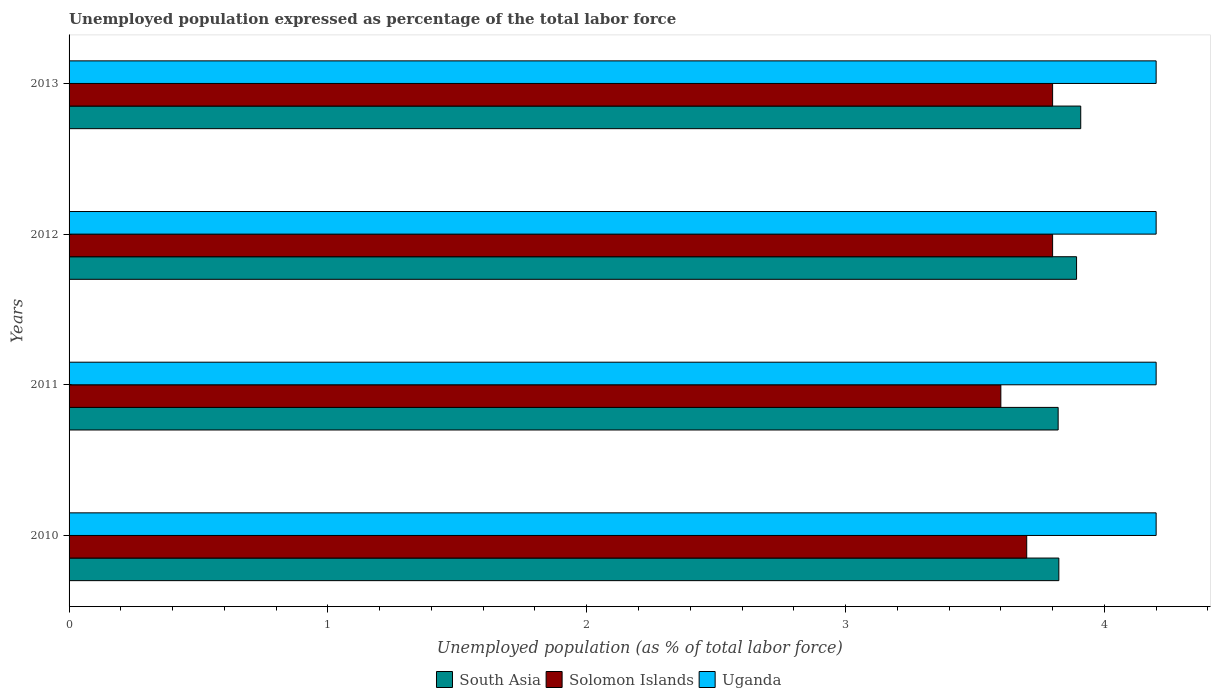How many different coloured bars are there?
Provide a short and direct response. 3. Are the number of bars per tick equal to the number of legend labels?
Make the answer very short. Yes. How many bars are there on the 4th tick from the top?
Your answer should be very brief. 3. What is the unemployment in in Solomon Islands in 2013?
Offer a very short reply. 3.8. Across all years, what is the maximum unemployment in in South Asia?
Provide a short and direct response. 3.91. Across all years, what is the minimum unemployment in in Solomon Islands?
Provide a short and direct response. 3.6. In which year was the unemployment in in Uganda maximum?
Give a very brief answer. 2010. In which year was the unemployment in in South Asia minimum?
Your response must be concise. 2011. What is the total unemployment in in South Asia in the graph?
Your response must be concise. 15.45. What is the difference between the unemployment in in Uganda in 2010 and that in 2011?
Provide a succinct answer. 0. What is the difference between the unemployment in in South Asia in 2011 and the unemployment in in Uganda in 2012?
Ensure brevity in your answer.  -0.38. What is the average unemployment in in Uganda per year?
Your answer should be compact. 4.2. In the year 2012, what is the difference between the unemployment in in Uganda and unemployment in in Solomon Islands?
Provide a succinct answer. 0.4. What is the ratio of the unemployment in in Solomon Islands in 2010 to that in 2012?
Your response must be concise. 0.97. Is the unemployment in in South Asia in 2010 less than that in 2012?
Provide a short and direct response. Yes. What is the difference between the highest and the lowest unemployment in in South Asia?
Keep it short and to the point. 0.09. Is the sum of the unemployment in in Uganda in 2011 and 2013 greater than the maximum unemployment in in South Asia across all years?
Your response must be concise. Yes. What does the 3rd bar from the top in 2013 represents?
Offer a very short reply. South Asia. What does the 2nd bar from the bottom in 2013 represents?
Provide a succinct answer. Solomon Islands. How many bars are there?
Offer a terse response. 12. Are all the bars in the graph horizontal?
Keep it short and to the point. Yes. How many years are there in the graph?
Give a very brief answer. 4. Are the values on the major ticks of X-axis written in scientific E-notation?
Provide a succinct answer. No. Where does the legend appear in the graph?
Your answer should be compact. Bottom center. How many legend labels are there?
Provide a short and direct response. 3. How are the legend labels stacked?
Provide a succinct answer. Horizontal. What is the title of the graph?
Your answer should be very brief. Unemployed population expressed as percentage of the total labor force. Does "Bangladesh" appear as one of the legend labels in the graph?
Your answer should be very brief. No. What is the label or title of the X-axis?
Your response must be concise. Unemployed population (as % of total labor force). What is the label or title of the Y-axis?
Provide a short and direct response. Years. What is the Unemployed population (as % of total labor force) in South Asia in 2010?
Offer a very short reply. 3.82. What is the Unemployed population (as % of total labor force) of Solomon Islands in 2010?
Provide a succinct answer. 3.7. What is the Unemployed population (as % of total labor force) of Uganda in 2010?
Make the answer very short. 4.2. What is the Unemployed population (as % of total labor force) of South Asia in 2011?
Provide a short and direct response. 3.82. What is the Unemployed population (as % of total labor force) in Solomon Islands in 2011?
Your answer should be very brief. 3.6. What is the Unemployed population (as % of total labor force) in Uganda in 2011?
Your answer should be compact. 4.2. What is the Unemployed population (as % of total labor force) of South Asia in 2012?
Ensure brevity in your answer.  3.89. What is the Unemployed population (as % of total labor force) of Solomon Islands in 2012?
Offer a terse response. 3.8. What is the Unemployed population (as % of total labor force) in Uganda in 2012?
Give a very brief answer. 4.2. What is the Unemployed population (as % of total labor force) in South Asia in 2013?
Provide a short and direct response. 3.91. What is the Unemployed population (as % of total labor force) in Solomon Islands in 2013?
Keep it short and to the point. 3.8. What is the Unemployed population (as % of total labor force) in Uganda in 2013?
Ensure brevity in your answer.  4.2. Across all years, what is the maximum Unemployed population (as % of total labor force) in South Asia?
Offer a terse response. 3.91. Across all years, what is the maximum Unemployed population (as % of total labor force) of Solomon Islands?
Offer a terse response. 3.8. Across all years, what is the maximum Unemployed population (as % of total labor force) in Uganda?
Your answer should be very brief. 4.2. Across all years, what is the minimum Unemployed population (as % of total labor force) in South Asia?
Your response must be concise. 3.82. Across all years, what is the minimum Unemployed population (as % of total labor force) in Solomon Islands?
Your response must be concise. 3.6. Across all years, what is the minimum Unemployed population (as % of total labor force) of Uganda?
Your answer should be very brief. 4.2. What is the total Unemployed population (as % of total labor force) in South Asia in the graph?
Your response must be concise. 15.45. What is the total Unemployed population (as % of total labor force) of Solomon Islands in the graph?
Your response must be concise. 14.9. What is the total Unemployed population (as % of total labor force) in Uganda in the graph?
Ensure brevity in your answer.  16.8. What is the difference between the Unemployed population (as % of total labor force) of South Asia in 2010 and that in 2011?
Provide a short and direct response. 0. What is the difference between the Unemployed population (as % of total labor force) in Solomon Islands in 2010 and that in 2011?
Give a very brief answer. 0.1. What is the difference between the Unemployed population (as % of total labor force) of South Asia in 2010 and that in 2012?
Give a very brief answer. -0.07. What is the difference between the Unemployed population (as % of total labor force) of Solomon Islands in 2010 and that in 2012?
Your answer should be very brief. -0.1. What is the difference between the Unemployed population (as % of total labor force) of South Asia in 2010 and that in 2013?
Offer a terse response. -0.08. What is the difference between the Unemployed population (as % of total labor force) in Solomon Islands in 2010 and that in 2013?
Keep it short and to the point. -0.1. What is the difference between the Unemployed population (as % of total labor force) in Uganda in 2010 and that in 2013?
Your response must be concise. 0. What is the difference between the Unemployed population (as % of total labor force) of South Asia in 2011 and that in 2012?
Your answer should be very brief. -0.07. What is the difference between the Unemployed population (as % of total labor force) in Uganda in 2011 and that in 2012?
Provide a succinct answer. 0. What is the difference between the Unemployed population (as % of total labor force) of South Asia in 2011 and that in 2013?
Your answer should be very brief. -0.09. What is the difference between the Unemployed population (as % of total labor force) of Solomon Islands in 2011 and that in 2013?
Give a very brief answer. -0.2. What is the difference between the Unemployed population (as % of total labor force) of Uganda in 2011 and that in 2013?
Keep it short and to the point. 0. What is the difference between the Unemployed population (as % of total labor force) in South Asia in 2012 and that in 2013?
Keep it short and to the point. -0.02. What is the difference between the Unemployed population (as % of total labor force) of Solomon Islands in 2012 and that in 2013?
Your answer should be very brief. 0. What is the difference between the Unemployed population (as % of total labor force) of Uganda in 2012 and that in 2013?
Provide a succinct answer. 0. What is the difference between the Unemployed population (as % of total labor force) in South Asia in 2010 and the Unemployed population (as % of total labor force) in Solomon Islands in 2011?
Ensure brevity in your answer.  0.22. What is the difference between the Unemployed population (as % of total labor force) of South Asia in 2010 and the Unemployed population (as % of total labor force) of Uganda in 2011?
Offer a very short reply. -0.38. What is the difference between the Unemployed population (as % of total labor force) in South Asia in 2010 and the Unemployed population (as % of total labor force) in Solomon Islands in 2012?
Keep it short and to the point. 0.02. What is the difference between the Unemployed population (as % of total labor force) of South Asia in 2010 and the Unemployed population (as % of total labor force) of Uganda in 2012?
Provide a succinct answer. -0.38. What is the difference between the Unemployed population (as % of total labor force) in Solomon Islands in 2010 and the Unemployed population (as % of total labor force) in Uganda in 2012?
Your response must be concise. -0.5. What is the difference between the Unemployed population (as % of total labor force) of South Asia in 2010 and the Unemployed population (as % of total labor force) of Solomon Islands in 2013?
Keep it short and to the point. 0.02. What is the difference between the Unemployed population (as % of total labor force) in South Asia in 2010 and the Unemployed population (as % of total labor force) in Uganda in 2013?
Provide a succinct answer. -0.38. What is the difference between the Unemployed population (as % of total labor force) in Solomon Islands in 2010 and the Unemployed population (as % of total labor force) in Uganda in 2013?
Keep it short and to the point. -0.5. What is the difference between the Unemployed population (as % of total labor force) of South Asia in 2011 and the Unemployed population (as % of total labor force) of Solomon Islands in 2012?
Give a very brief answer. 0.02. What is the difference between the Unemployed population (as % of total labor force) in South Asia in 2011 and the Unemployed population (as % of total labor force) in Uganda in 2012?
Offer a very short reply. -0.38. What is the difference between the Unemployed population (as % of total labor force) in Solomon Islands in 2011 and the Unemployed population (as % of total labor force) in Uganda in 2012?
Provide a short and direct response. -0.6. What is the difference between the Unemployed population (as % of total labor force) in South Asia in 2011 and the Unemployed population (as % of total labor force) in Solomon Islands in 2013?
Your answer should be very brief. 0.02. What is the difference between the Unemployed population (as % of total labor force) of South Asia in 2011 and the Unemployed population (as % of total labor force) of Uganda in 2013?
Offer a terse response. -0.38. What is the difference between the Unemployed population (as % of total labor force) in South Asia in 2012 and the Unemployed population (as % of total labor force) in Solomon Islands in 2013?
Provide a short and direct response. 0.09. What is the difference between the Unemployed population (as % of total labor force) in South Asia in 2012 and the Unemployed population (as % of total labor force) in Uganda in 2013?
Ensure brevity in your answer.  -0.31. What is the average Unemployed population (as % of total labor force) in South Asia per year?
Offer a terse response. 3.86. What is the average Unemployed population (as % of total labor force) in Solomon Islands per year?
Offer a terse response. 3.73. In the year 2010, what is the difference between the Unemployed population (as % of total labor force) of South Asia and Unemployed population (as % of total labor force) of Solomon Islands?
Ensure brevity in your answer.  0.12. In the year 2010, what is the difference between the Unemployed population (as % of total labor force) of South Asia and Unemployed population (as % of total labor force) of Uganda?
Your response must be concise. -0.38. In the year 2011, what is the difference between the Unemployed population (as % of total labor force) in South Asia and Unemployed population (as % of total labor force) in Solomon Islands?
Your response must be concise. 0.22. In the year 2011, what is the difference between the Unemployed population (as % of total labor force) of South Asia and Unemployed population (as % of total labor force) of Uganda?
Your answer should be very brief. -0.38. In the year 2011, what is the difference between the Unemployed population (as % of total labor force) of Solomon Islands and Unemployed population (as % of total labor force) of Uganda?
Give a very brief answer. -0.6. In the year 2012, what is the difference between the Unemployed population (as % of total labor force) in South Asia and Unemployed population (as % of total labor force) in Solomon Islands?
Keep it short and to the point. 0.09. In the year 2012, what is the difference between the Unemployed population (as % of total labor force) in South Asia and Unemployed population (as % of total labor force) in Uganda?
Offer a very short reply. -0.31. In the year 2012, what is the difference between the Unemployed population (as % of total labor force) of Solomon Islands and Unemployed population (as % of total labor force) of Uganda?
Your answer should be compact. -0.4. In the year 2013, what is the difference between the Unemployed population (as % of total labor force) of South Asia and Unemployed population (as % of total labor force) of Solomon Islands?
Ensure brevity in your answer.  0.11. In the year 2013, what is the difference between the Unemployed population (as % of total labor force) of South Asia and Unemployed population (as % of total labor force) of Uganda?
Provide a succinct answer. -0.29. In the year 2013, what is the difference between the Unemployed population (as % of total labor force) of Solomon Islands and Unemployed population (as % of total labor force) of Uganda?
Your response must be concise. -0.4. What is the ratio of the Unemployed population (as % of total labor force) of Solomon Islands in 2010 to that in 2011?
Make the answer very short. 1.03. What is the ratio of the Unemployed population (as % of total labor force) in Uganda in 2010 to that in 2011?
Give a very brief answer. 1. What is the ratio of the Unemployed population (as % of total labor force) of South Asia in 2010 to that in 2012?
Make the answer very short. 0.98. What is the ratio of the Unemployed population (as % of total labor force) of Solomon Islands in 2010 to that in 2012?
Your answer should be compact. 0.97. What is the ratio of the Unemployed population (as % of total labor force) of Uganda in 2010 to that in 2012?
Keep it short and to the point. 1. What is the ratio of the Unemployed population (as % of total labor force) of South Asia in 2010 to that in 2013?
Offer a terse response. 0.98. What is the ratio of the Unemployed population (as % of total labor force) in Solomon Islands in 2010 to that in 2013?
Provide a short and direct response. 0.97. What is the ratio of the Unemployed population (as % of total labor force) in Uganda in 2010 to that in 2013?
Your answer should be compact. 1. What is the ratio of the Unemployed population (as % of total labor force) of South Asia in 2011 to that in 2012?
Ensure brevity in your answer.  0.98. What is the ratio of the Unemployed population (as % of total labor force) in Solomon Islands in 2011 to that in 2012?
Provide a short and direct response. 0.95. What is the ratio of the Unemployed population (as % of total labor force) in Uganda in 2011 to that in 2012?
Your answer should be very brief. 1. What is the ratio of the Unemployed population (as % of total labor force) in South Asia in 2011 to that in 2013?
Offer a terse response. 0.98. What is the ratio of the Unemployed population (as % of total labor force) of Solomon Islands in 2011 to that in 2013?
Offer a terse response. 0.95. What is the ratio of the Unemployed population (as % of total labor force) in South Asia in 2012 to that in 2013?
Provide a short and direct response. 1. What is the difference between the highest and the second highest Unemployed population (as % of total labor force) of South Asia?
Offer a terse response. 0.02. What is the difference between the highest and the lowest Unemployed population (as % of total labor force) of South Asia?
Your answer should be compact. 0.09. What is the difference between the highest and the lowest Unemployed population (as % of total labor force) of Solomon Islands?
Ensure brevity in your answer.  0.2. 